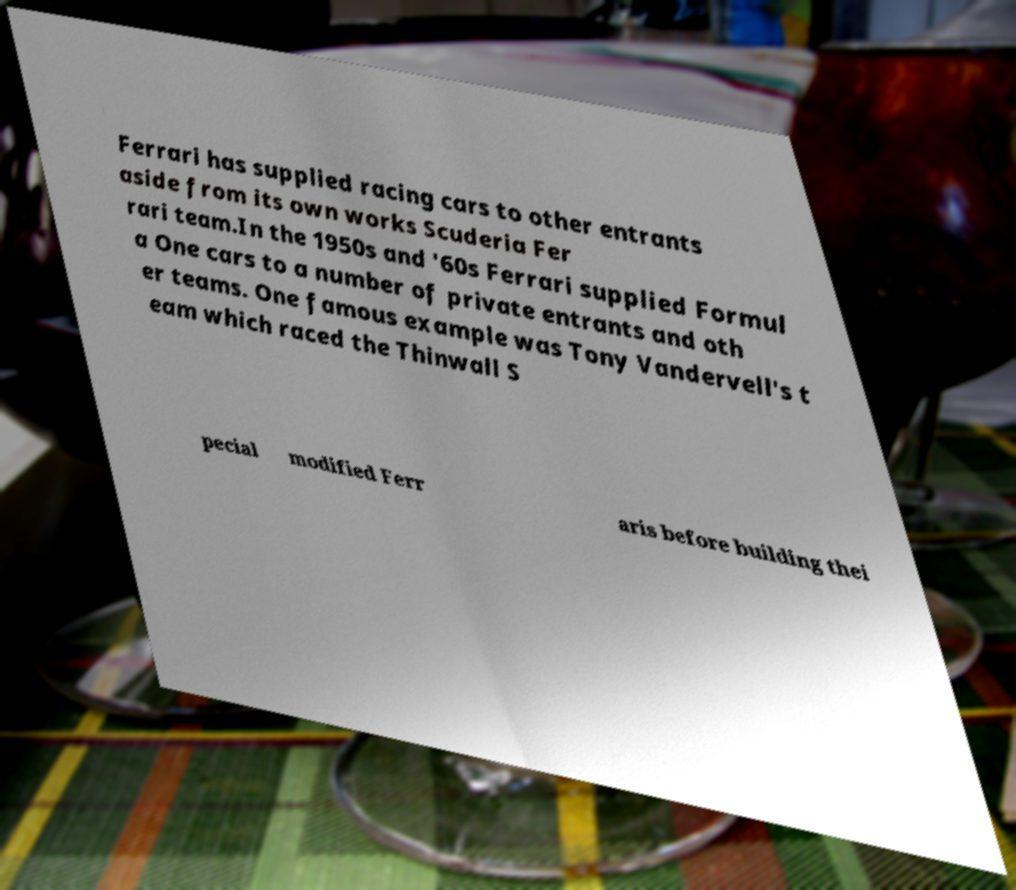Could you extract and type out the text from this image? Ferrari has supplied racing cars to other entrants aside from its own works Scuderia Fer rari team.In the 1950s and '60s Ferrari supplied Formul a One cars to a number of private entrants and oth er teams. One famous example was Tony Vandervell's t eam which raced the Thinwall S pecial modified Ferr aris before building thei 